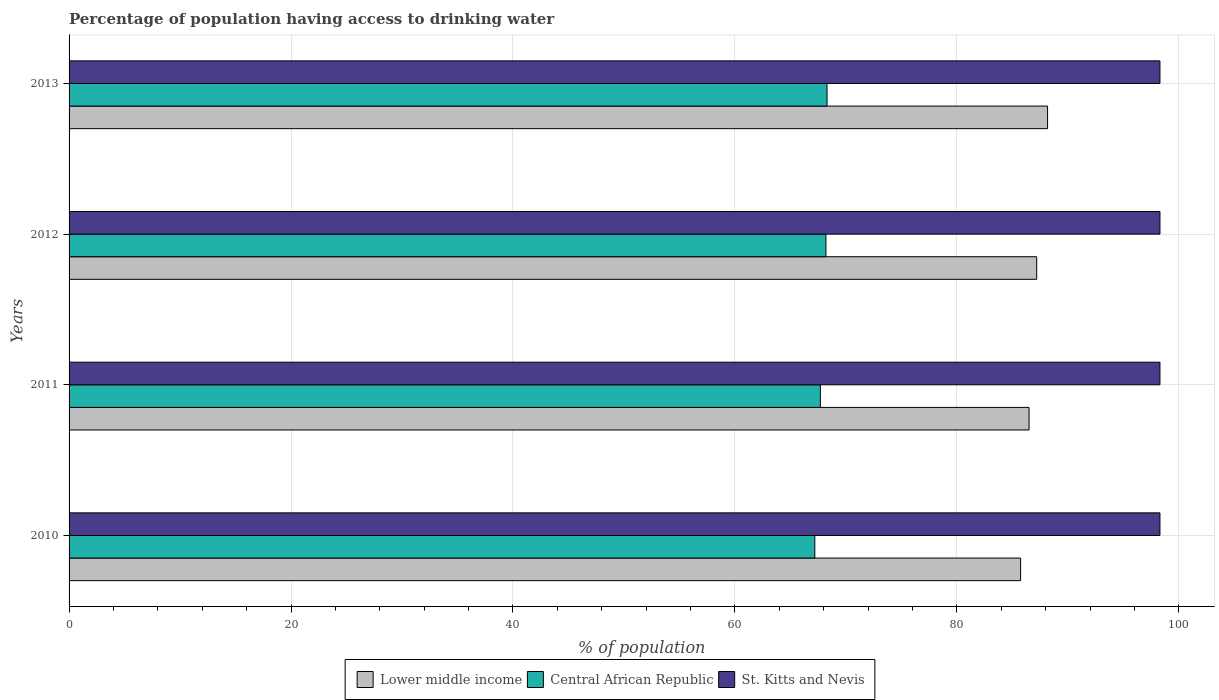What is the label of the 4th group of bars from the top?
Offer a terse response. 2010. What is the percentage of population having access to drinking water in Central African Republic in 2012?
Your response must be concise. 68.2. Across all years, what is the maximum percentage of population having access to drinking water in Central African Republic?
Make the answer very short. 68.3. Across all years, what is the minimum percentage of population having access to drinking water in St. Kitts and Nevis?
Ensure brevity in your answer.  98.3. In which year was the percentage of population having access to drinking water in Lower middle income maximum?
Your answer should be very brief. 2013. In which year was the percentage of population having access to drinking water in Lower middle income minimum?
Offer a terse response. 2010. What is the total percentage of population having access to drinking water in Central African Republic in the graph?
Offer a very short reply. 271.4. What is the difference between the percentage of population having access to drinking water in Lower middle income in 2010 and that in 2013?
Your answer should be compact. -2.43. What is the difference between the percentage of population having access to drinking water in Central African Republic in 2013 and the percentage of population having access to drinking water in Lower middle income in 2012?
Provide a succinct answer. -18.89. What is the average percentage of population having access to drinking water in Central African Republic per year?
Give a very brief answer. 67.85. In the year 2010, what is the difference between the percentage of population having access to drinking water in Lower middle income and percentage of population having access to drinking water in Central African Republic?
Your answer should be compact. 18.55. In how many years, is the percentage of population having access to drinking water in St. Kitts and Nevis greater than 56 %?
Give a very brief answer. 4. What is the ratio of the percentage of population having access to drinking water in Lower middle income in 2011 to that in 2013?
Make the answer very short. 0.98. Is the difference between the percentage of population having access to drinking water in Lower middle income in 2010 and 2012 greater than the difference between the percentage of population having access to drinking water in Central African Republic in 2010 and 2012?
Provide a short and direct response. No. What is the difference between the highest and the second highest percentage of population having access to drinking water in Lower middle income?
Provide a succinct answer. 0.98. What is the difference between the highest and the lowest percentage of population having access to drinking water in Lower middle income?
Make the answer very short. 2.43. In how many years, is the percentage of population having access to drinking water in Lower middle income greater than the average percentage of population having access to drinking water in Lower middle income taken over all years?
Offer a terse response. 2. Is the sum of the percentage of population having access to drinking water in Central African Republic in 2010 and 2012 greater than the maximum percentage of population having access to drinking water in Lower middle income across all years?
Make the answer very short. Yes. What does the 2nd bar from the top in 2012 represents?
Offer a very short reply. Central African Republic. What does the 2nd bar from the bottom in 2012 represents?
Your response must be concise. Central African Republic. Is it the case that in every year, the sum of the percentage of population having access to drinking water in Central African Republic and percentage of population having access to drinking water in Lower middle income is greater than the percentage of population having access to drinking water in St. Kitts and Nevis?
Ensure brevity in your answer.  Yes. How many bars are there?
Ensure brevity in your answer.  12. Are all the bars in the graph horizontal?
Provide a succinct answer. Yes. What is the difference between two consecutive major ticks on the X-axis?
Give a very brief answer. 20. Are the values on the major ticks of X-axis written in scientific E-notation?
Your answer should be very brief. No. Does the graph contain grids?
Offer a very short reply. Yes. Where does the legend appear in the graph?
Your answer should be compact. Bottom center. What is the title of the graph?
Ensure brevity in your answer.  Percentage of population having access to drinking water. Does "Australia" appear as one of the legend labels in the graph?
Offer a terse response. No. What is the label or title of the X-axis?
Ensure brevity in your answer.  % of population. What is the label or title of the Y-axis?
Offer a terse response. Years. What is the % of population of Lower middle income in 2010?
Your response must be concise. 85.75. What is the % of population in Central African Republic in 2010?
Keep it short and to the point. 67.2. What is the % of population of St. Kitts and Nevis in 2010?
Your answer should be very brief. 98.3. What is the % of population of Lower middle income in 2011?
Your answer should be very brief. 86.51. What is the % of population in Central African Republic in 2011?
Ensure brevity in your answer.  67.7. What is the % of population in St. Kitts and Nevis in 2011?
Your response must be concise. 98.3. What is the % of population of Lower middle income in 2012?
Your response must be concise. 87.19. What is the % of population of Central African Republic in 2012?
Your answer should be very brief. 68.2. What is the % of population of St. Kitts and Nevis in 2012?
Provide a succinct answer. 98.3. What is the % of population in Lower middle income in 2013?
Ensure brevity in your answer.  88.17. What is the % of population in Central African Republic in 2013?
Make the answer very short. 68.3. What is the % of population of St. Kitts and Nevis in 2013?
Make the answer very short. 98.3. Across all years, what is the maximum % of population of Lower middle income?
Make the answer very short. 88.17. Across all years, what is the maximum % of population of Central African Republic?
Your answer should be very brief. 68.3. Across all years, what is the maximum % of population of St. Kitts and Nevis?
Your response must be concise. 98.3. Across all years, what is the minimum % of population of Lower middle income?
Ensure brevity in your answer.  85.75. Across all years, what is the minimum % of population in Central African Republic?
Give a very brief answer. 67.2. Across all years, what is the minimum % of population in St. Kitts and Nevis?
Provide a succinct answer. 98.3. What is the total % of population in Lower middle income in the graph?
Keep it short and to the point. 347.62. What is the total % of population in Central African Republic in the graph?
Give a very brief answer. 271.4. What is the total % of population of St. Kitts and Nevis in the graph?
Offer a very short reply. 393.2. What is the difference between the % of population in Lower middle income in 2010 and that in 2011?
Your response must be concise. -0.76. What is the difference between the % of population of Central African Republic in 2010 and that in 2011?
Ensure brevity in your answer.  -0.5. What is the difference between the % of population of St. Kitts and Nevis in 2010 and that in 2011?
Keep it short and to the point. 0. What is the difference between the % of population of Lower middle income in 2010 and that in 2012?
Keep it short and to the point. -1.45. What is the difference between the % of population in Central African Republic in 2010 and that in 2012?
Give a very brief answer. -1. What is the difference between the % of population of Lower middle income in 2010 and that in 2013?
Give a very brief answer. -2.43. What is the difference between the % of population of Central African Republic in 2010 and that in 2013?
Give a very brief answer. -1.1. What is the difference between the % of population in Lower middle income in 2011 and that in 2012?
Ensure brevity in your answer.  -0.69. What is the difference between the % of population of Central African Republic in 2011 and that in 2012?
Offer a very short reply. -0.5. What is the difference between the % of population in St. Kitts and Nevis in 2011 and that in 2012?
Make the answer very short. 0. What is the difference between the % of population of Lower middle income in 2011 and that in 2013?
Offer a terse response. -1.67. What is the difference between the % of population of Central African Republic in 2011 and that in 2013?
Offer a terse response. -0.6. What is the difference between the % of population in St. Kitts and Nevis in 2011 and that in 2013?
Provide a short and direct response. 0. What is the difference between the % of population of Lower middle income in 2012 and that in 2013?
Your answer should be compact. -0.98. What is the difference between the % of population in Lower middle income in 2010 and the % of population in Central African Republic in 2011?
Ensure brevity in your answer.  18.05. What is the difference between the % of population in Lower middle income in 2010 and the % of population in St. Kitts and Nevis in 2011?
Your answer should be compact. -12.55. What is the difference between the % of population of Central African Republic in 2010 and the % of population of St. Kitts and Nevis in 2011?
Offer a terse response. -31.1. What is the difference between the % of population in Lower middle income in 2010 and the % of population in Central African Republic in 2012?
Offer a terse response. 17.55. What is the difference between the % of population of Lower middle income in 2010 and the % of population of St. Kitts and Nevis in 2012?
Your response must be concise. -12.55. What is the difference between the % of population of Central African Republic in 2010 and the % of population of St. Kitts and Nevis in 2012?
Provide a short and direct response. -31.1. What is the difference between the % of population of Lower middle income in 2010 and the % of population of Central African Republic in 2013?
Offer a terse response. 17.45. What is the difference between the % of population in Lower middle income in 2010 and the % of population in St. Kitts and Nevis in 2013?
Provide a succinct answer. -12.55. What is the difference between the % of population in Central African Republic in 2010 and the % of population in St. Kitts and Nevis in 2013?
Offer a terse response. -31.1. What is the difference between the % of population in Lower middle income in 2011 and the % of population in Central African Republic in 2012?
Give a very brief answer. 18.31. What is the difference between the % of population of Lower middle income in 2011 and the % of population of St. Kitts and Nevis in 2012?
Make the answer very short. -11.79. What is the difference between the % of population of Central African Republic in 2011 and the % of population of St. Kitts and Nevis in 2012?
Provide a succinct answer. -30.6. What is the difference between the % of population of Lower middle income in 2011 and the % of population of Central African Republic in 2013?
Your response must be concise. 18.21. What is the difference between the % of population in Lower middle income in 2011 and the % of population in St. Kitts and Nevis in 2013?
Provide a succinct answer. -11.79. What is the difference between the % of population of Central African Republic in 2011 and the % of population of St. Kitts and Nevis in 2013?
Your response must be concise. -30.6. What is the difference between the % of population in Lower middle income in 2012 and the % of population in Central African Republic in 2013?
Ensure brevity in your answer.  18.89. What is the difference between the % of population in Lower middle income in 2012 and the % of population in St. Kitts and Nevis in 2013?
Your answer should be very brief. -11.11. What is the difference between the % of population of Central African Republic in 2012 and the % of population of St. Kitts and Nevis in 2013?
Provide a succinct answer. -30.1. What is the average % of population in Lower middle income per year?
Provide a short and direct response. 86.9. What is the average % of population in Central African Republic per year?
Your answer should be compact. 67.85. What is the average % of population in St. Kitts and Nevis per year?
Keep it short and to the point. 98.3. In the year 2010, what is the difference between the % of population in Lower middle income and % of population in Central African Republic?
Provide a succinct answer. 18.55. In the year 2010, what is the difference between the % of population of Lower middle income and % of population of St. Kitts and Nevis?
Give a very brief answer. -12.55. In the year 2010, what is the difference between the % of population in Central African Republic and % of population in St. Kitts and Nevis?
Provide a short and direct response. -31.1. In the year 2011, what is the difference between the % of population of Lower middle income and % of population of Central African Republic?
Keep it short and to the point. 18.81. In the year 2011, what is the difference between the % of population in Lower middle income and % of population in St. Kitts and Nevis?
Offer a terse response. -11.79. In the year 2011, what is the difference between the % of population in Central African Republic and % of population in St. Kitts and Nevis?
Ensure brevity in your answer.  -30.6. In the year 2012, what is the difference between the % of population in Lower middle income and % of population in Central African Republic?
Your answer should be compact. 18.99. In the year 2012, what is the difference between the % of population in Lower middle income and % of population in St. Kitts and Nevis?
Keep it short and to the point. -11.11. In the year 2012, what is the difference between the % of population in Central African Republic and % of population in St. Kitts and Nevis?
Provide a succinct answer. -30.1. In the year 2013, what is the difference between the % of population of Lower middle income and % of population of Central African Republic?
Offer a very short reply. 19.87. In the year 2013, what is the difference between the % of population of Lower middle income and % of population of St. Kitts and Nevis?
Keep it short and to the point. -10.13. In the year 2013, what is the difference between the % of population in Central African Republic and % of population in St. Kitts and Nevis?
Provide a short and direct response. -30. What is the ratio of the % of population in Lower middle income in 2010 to that in 2011?
Keep it short and to the point. 0.99. What is the ratio of the % of population of Lower middle income in 2010 to that in 2012?
Ensure brevity in your answer.  0.98. What is the ratio of the % of population in Lower middle income in 2010 to that in 2013?
Give a very brief answer. 0.97. What is the ratio of the % of population in Central African Republic in 2010 to that in 2013?
Offer a very short reply. 0.98. What is the ratio of the % of population of Central African Republic in 2011 to that in 2012?
Your answer should be very brief. 0.99. What is the ratio of the % of population of St. Kitts and Nevis in 2011 to that in 2012?
Your response must be concise. 1. What is the ratio of the % of population in Lower middle income in 2011 to that in 2013?
Give a very brief answer. 0.98. What is the ratio of the % of population of Central African Republic in 2011 to that in 2013?
Provide a succinct answer. 0.99. What is the ratio of the % of population of St. Kitts and Nevis in 2011 to that in 2013?
Ensure brevity in your answer.  1. What is the ratio of the % of population in Lower middle income in 2012 to that in 2013?
Make the answer very short. 0.99. What is the ratio of the % of population in Central African Republic in 2012 to that in 2013?
Your answer should be very brief. 1. What is the difference between the highest and the second highest % of population in Lower middle income?
Your answer should be very brief. 0.98. What is the difference between the highest and the second highest % of population of Central African Republic?
Your answer should be compact. 0.1. What is the difference between the highest and the second highest % of population in St. Kitts and Nevis?
Offer a very short reply. 0. What is the difference between the highest and the lowest % of population in Lower middle income?
Your answer should be compact. 2.43. What is the difference between the highest and the lowest % of population of St. Kitts and Nevis?
Provide a short and direct response. 0. 